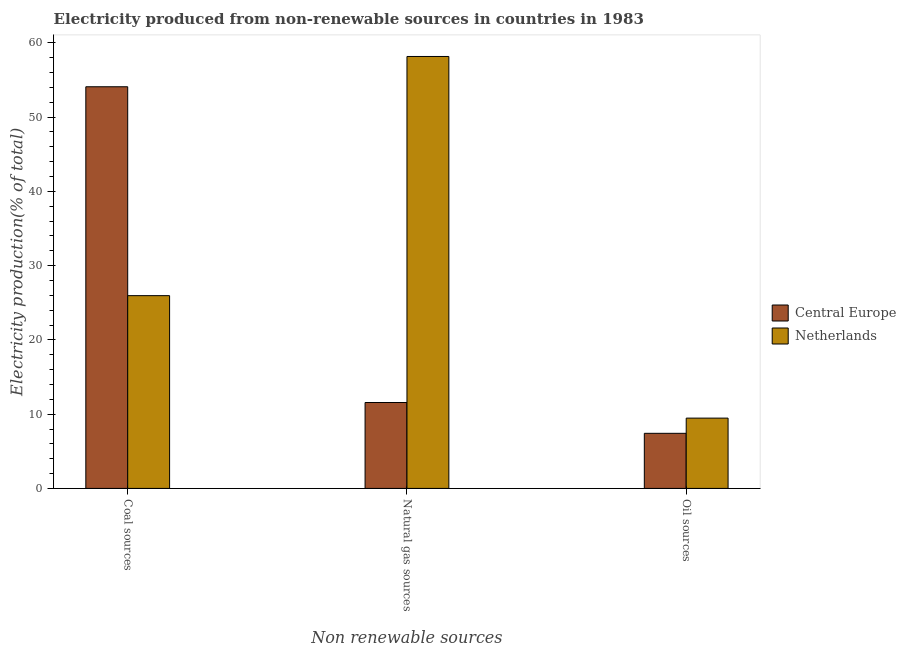How many different coloured bars are there?
Ensure brevity in your answer.  2. How many groups of bars are there?
Provide a short and direct response. 3. Are the number of bars per tick equal to the number of legend labels?
Your answer should be very brief. Yes. Are the number of bars on each tick of the X-axis equal?
Keep it short and to the point. Yes. How many bars are there on the 1st tick from the right?
Your answer should be compact. 2. What is the label of the 1st group of bars from the left?
Keep it short and to the point. Coal sources. What is the percentage of electricity produced by oil sources in Central Europe?
Make the answer very short. 7.42. Across all countries, what is the maximum percentage of electricity produced by oil sources?
Offer a very short reply. 9.47. Across all countries, what is the minimum percentage of electricity produced by coal?
Ensure brevity in your answer.  25.96. In which country was the percentage of electricity produced by natural gas minimum?
Your response must be concise. Central Europe. What is the total percentage of electricity produced by oil sources in the graph?
Keep it short and to the point. 16.89. What is the difference between the percentage of electricity produced by coal in Central Europe and that in Netherlands?
Provide a short and direct response. 28.13. What is the difference between the percentage of electricity produced by oil sources in Netherlands and the percentage of electricity produced by natural gas in Central Europe?
Offer a terse response. -2.1. What is the average percentage of electricity produced by coal per country?
Your answer should be compact. 40.03. What is the difference between the percentage of electricity produced by oil sources and percentage of electricity produced by natural gas in Central Europe?
Give a very brief answer. -4.15. In how many countries, is the percentage of electricity produced by coal greater than 28 %?
Offer a terse response. 1. What is the ratio of the percentage of electricity produced by oil sources in Central Europe to that in Netherlands?
Make the answer very short. 0.78. Is the difference between the percentage of electricity produced by natural gas in Netherlands and Central Europe greater than the difference between the percentage of electricity produced by oil sources in Netherlands and Central Europe?
Offer a terse response. Yes. What is the difference between the highest and the second highest percentage of electricity produced by coal?
Your answer should be compact. 28.13. What is the difference between the highest and the lowest percentage of electricity produced by oil sources?
Keep it short and to the point. 2.05. In how many countries, is the percentage of electricity produced by oil sources greater than the average percentage of electricity produced by oil sources taken over all countries?
Your answer should be very brief. 1. What does the 1st bar from the left in Natural gas sources represents?
Give a very brief answer. Central Europe. What does the 2nd bar from the right in Coal sources represents?
Give a very brief answer. Central Europe. Is it the case that in every country, the sum of the percentage of electricity produced by coal and percentage of electricity produced by natural gas is greater than the percentage of electricity produced by oil sources?
Your answer should be compact. Yes. Are all the bars in the graph horizontal?
Your answer should be compact. No. How many countries are there in the graph?
Ensure brevity in your answer.  2. Does the graph contain any zero values?
Make the answer very short. No. Does the graph contain grids?
Provide a short and direct response. No. Where does the legend appear in the graph?
Give a very brief answer. Center right. What is the title of the graph?
Your answer should be compact. Electricity produced from non-renewable sources in countries in 1983. Does "Jamaica" appear as one of the legend labels in the graph?
Ensure brevity in your answer.  No. What is the label or title of the X-axis?
Offer a very short reply. Non renewable sources. What is the label or title of the Y-axis?
Provide a short and direct response. Electricity production(% of total). What is the Electricity production(% of total) in Central Europe in Coal sources?
Your answer should be very brief. 54.09. What is the Electricity production(% of total) in Netherlands in Coal sources?
Your answer should be very brief. 25.96. What is the Electricity production(% of total) in Central Europe in Natural gas sources?
Keep it short and to the point. 11.57. What is the Electricity production(% of total) of Netherlands in Natural gas sources?
Keep it short and to the point. 58.17. What is the Electricity production(% of total) of Central Europe in Oil sources?
Make the answer very short. 7.42. What is the Electricity production(% of total) of Netherlands in Oil sources?
Make the answer very short. 9.47. Across all Non renewable sources, what is the maximum Electricity production(% of total) of Central Europe?
Give a very brief answer. 54.09. Across all Non renewable sources, what is the maximum Electricity production(% of total) of Netherlands?
Offer a very short reply. 58.17. Across all Non renewable sources, what is the minimum Electricity production(% of total) in Central Europe?
Your answer should be very brief. 7.42. Across all Non renewable sources, what is the minimum Electricity production(% of total) of Netherlands?
Give a very brief answer. 9.47. What is the total Electricity production(% of total) in Central Europe in the graph?
Ensure brevity in your answer.  73.08. What is the total Electricity production(% of total) of Netherlands in the graph?
Your answer should be compact. 93.6. What is the difference between the Electricity production(% of total) in Central Europe in Coal sources and that in Natural gas sources?
Your answer should be compact. 42.52. What is the difference between the Electricity production(% of total) of Netherlands in Coal sources and that in Natural gas sources?
Your response must be concise. -32.21. What is the difference between the Electricity production(% of total) in Central Europe in Coal sources and that in Oil sources?
Offer a very short reply. 46.67. What is the difference between the Electricity production(% of total) of Netherlands in Coal sources and that in Oil sources?
Keep it short and to the point. 16.49. What is the difference between the Electricity production(% of total) in Central Europe in Natural gas sources and that in Oil sources?
Offer a very short reply. 4.15. What is the difference between the Electricity production(% of total) in Netherlands in Natural gas sources and that in Oil sources?
Your response must be concise. 48.7. What is the difference between the Electricity production(% of total) in Central Europe in Coal sources and the Electricity production(% of total) in Netherlands in Natural gas sources?
Offer a terse response. -4.08. What is the difference between the Electricity production(% of total) of Central Europe in Coal sources and the Electricity production(% of total) of Netherlands in Oil sources?
Provide a short and direct response. 44.62. What is the difference between the Electricity production(% of total) of Central Europe in Natural gas sources and the Electricity production(% of total) of Netherlands in Oil sources?
Provide a short and direct response. 2.1. What is the average Electricity production(% of total) of Central Europe per Non renewable sources?
Keep it short and to the point. 24.36. What is the average Electricity production(% of total) in Netherlands per Non renewable sources?
Make the answer very short. 31.2. What is the difference between the Electricity production(% of total) in Central Europe and Electricity production(% of total) in Netherlands in Coal sources?
Keep it short and to the point. 28.13. What is the difference between the Electricity production(% of total) of Central Europe and Electricity production(% of total) of Netherlands in Natural gas sources?
Your answer should be very brief. -46.6. What is the difference between the Electricity production(% of total) in Central Europe and Electricity production(% of total) in Netherlands in Oil sources?
Ensure brevity in your answer.  -2.05. What is the ratio of the Electricity production(% of total) of Central Europe in Coal sources to that in Natural gas sources?
Offer a terse response. 4.68. What is the ratio of the Electricity production(% of total) in Netherlands in Coal sources to that in Natural gas sources?
Make the answer very short. 0.45. What is the ratio of the Electricity production(% of total) of Central Europe in Coal sources to that in Oil sources?
Provide a short and direct response. 7.29. What is the ratio of the Electricity production(% of total) of Netherlands in Coal sources to that in Oil sources?
Provide a short and direct response. 2.74. What is the ratio of the Electricity production(% of total) of Central Europe in Natural gas sources to that in Oil sources?
Ensure brevity in your answer.  1.56. What is the ratio of the Electricity production(% of total) in Netherlands in Natural gas sources to that in Oil sources?
Provide a short and direct response. 6.14. What is the difference between the highest and the second highest Electricity production(% of total) in Central Europe?
Provide a short and direct response. 42.52. What is the difference between the highest and the second highest Electricity production(% of total) in Netherlands?
Provide a succinct answer. 32.21. What is the difference between the highest and the lowest Electricity production(% of total) in Central Europe?
Keep it short and to the point. 46.67. What is the difference between the highest and the lowest Electricity production(% of total) of Netherlands?
Ensure brevity in your answer.  48.7. 